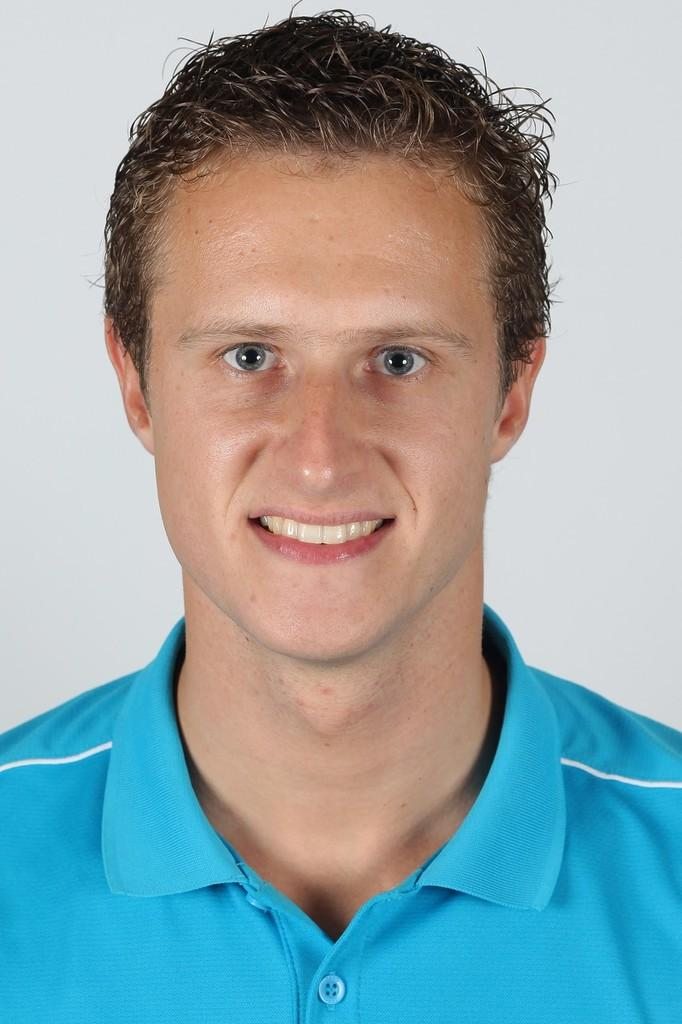Who is in the image? There is a man in the image. What is the man doing in the image? The man is smiling in the image. What is the man wearing in the image? The man is wearing a blue t-shirt in the image. What color is the background of the image? The background of the image is white. What is the name of the man's brother in the image? There is no mention of a brother or any other person in the image, so it is not possible to determine the name of the man's brother. 